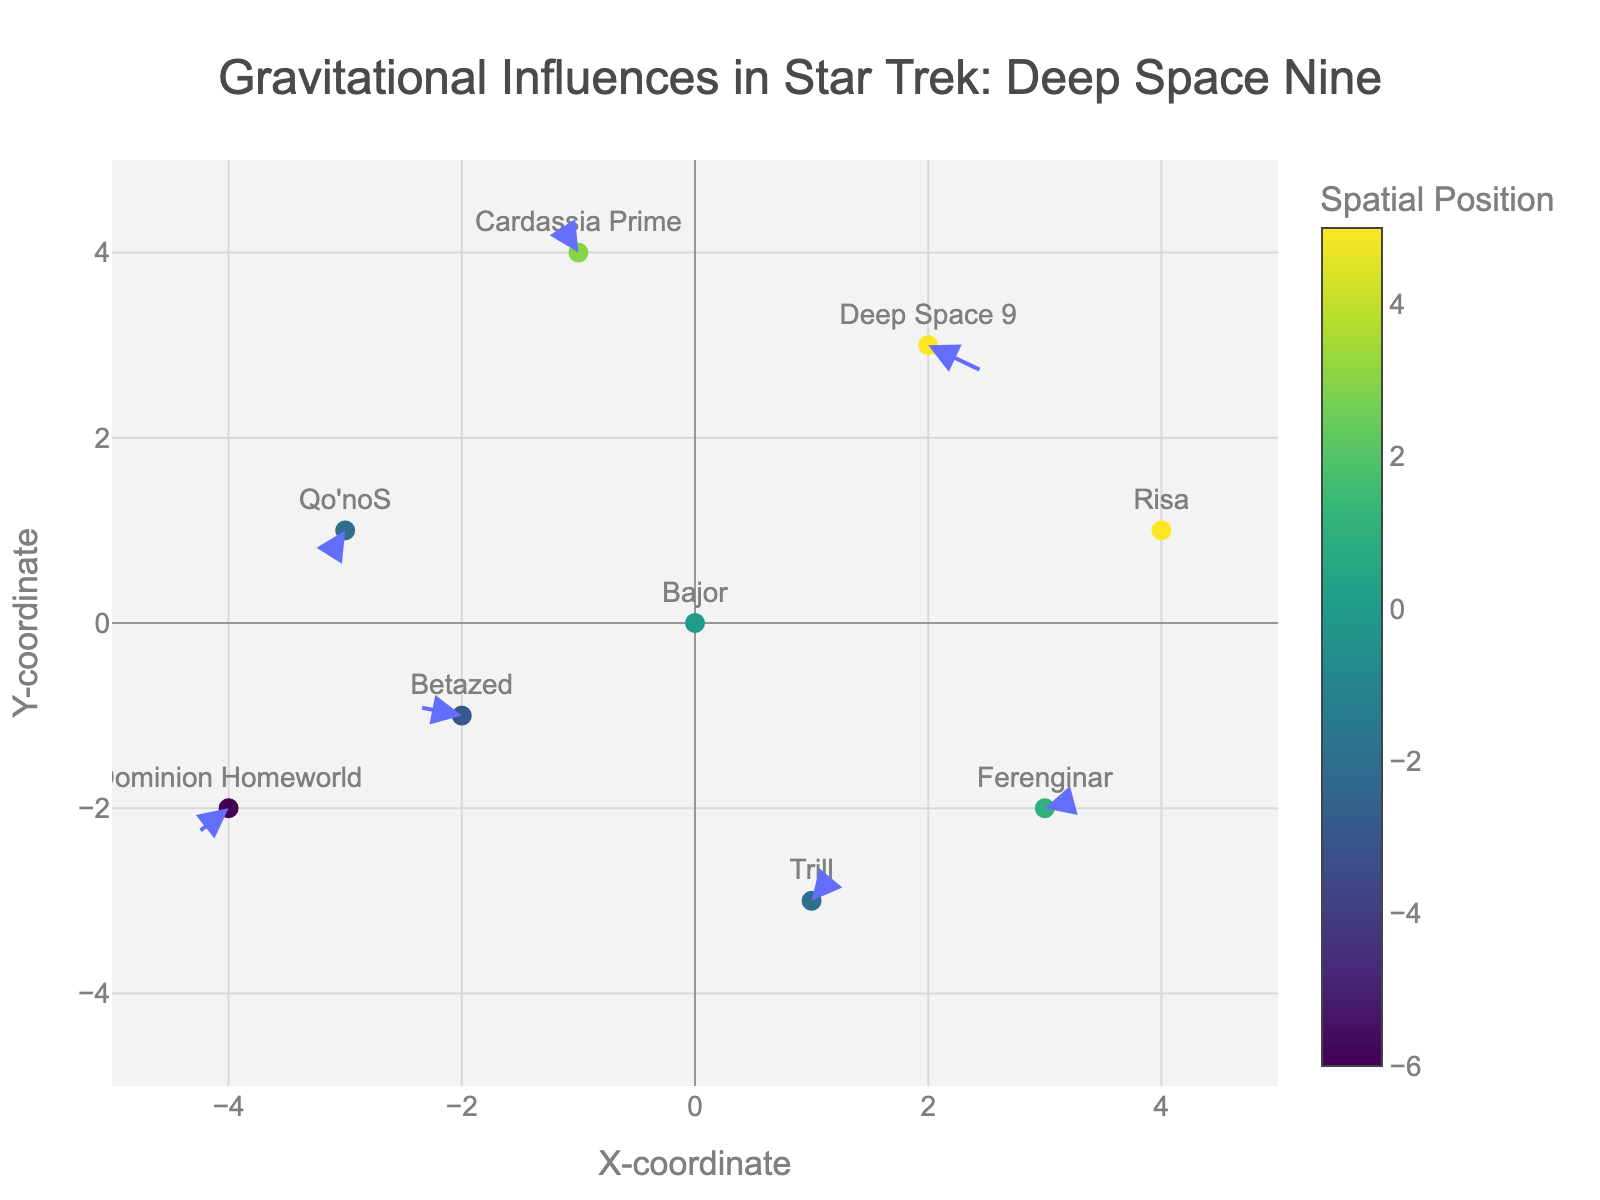What is the title of the plot? The title is found at the top center of the figure and it tells us what the visualization is about.
Answer: Gravitational Influences in Star Trek: Deep Space Nine How many planetary systems are displayed in the plot? Count the number of data points, each representing a planetary system.
Answer: 9 Which planetary system has the strongest gravitational pull represented by the longest arrow? Observe the length of the arrows; the longest vector indicates the strongest gravitational pull.
Answer: Betazed How does the gravitational influence of Ferenginar compare to that of Trill in terms of direction? Analyze the direction of the arrows from Ferenginar and Trill. Ferenginar's arrow points slightly right and up, whereas Trill's arrow points more steeply up and to the left.
Answer: Ferenginar points slightly up-right, Trill points more up-left What is the average X-coordinate of the systems displayed? Add up the X-coordinates of all the planetary systems and divide by the number of systems (9). Calculation: (0 + 2 - 1 + 3 - 3 + 1 - 2 + 4 - 4) / 9 = 0 / 9 = 0
Answer: 0 If we sum the U-component of the velocity vectors for Deep Space 9 and Cardassia Prime, what do we get? Identify the U-components for these two systems (Deep Space 9: 0.5, Cardassia Prime: -0.2), then sum them: 0.5 + (-0.2) = 0.3
Answer: 0.3 Which planetary system is most affected by gravitational forces from surrounding regions? Identify the system with the arrow that deviates the most from the zero vector, considering both length and direction. Betazed's vector (-0.4, 0.1) indicates the strongest deviation.
Answer: Betazed What is the combined Y-coordinate and V-component for Qo'noS? Add the Y-coordinate and V-component of Qo'noS: 1 + (-0.2) = 0.8
Answer: 0.8 How does the position of Risa affect its gravitational influence direction compared to Dominion Homeworld? Compare the position and vectors of Risa and Dominion Homeworld. Risa (right) has a downward-left vector, while Dominion (left) has a downward-right vector, indicating opposing gravitational influences.
Answer: Risa vector: downward-left, Dominion vector: downward-right Which planetary system has no gravitational influence and how can you tell? Look for the system with a zero vector (U, V both zero). Bajor's vector (0, 0) indicates no gravitational influence.
Answer: Bajor 